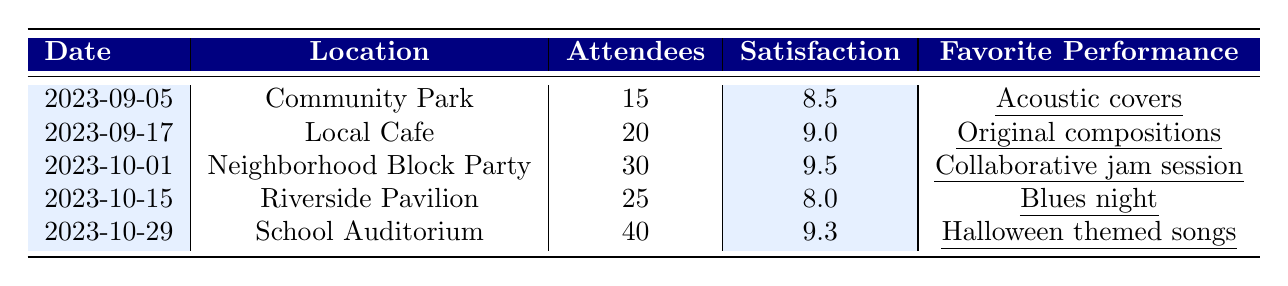What was the location for the music sharing session on September 17, 2023? The table lists the session date, location, attendees, satisfaction, and favorite performance for each session. For the date 2023-09-17, the location is Local Cafe.
Answer: Local Cafe How many attendees were present at the Neighborhood Block Party session? By referring to the row corresponding to the date 2023-10-01, we see that the number of attendees for the Neighborhood Block Party is 30.
Answer: 30 What was the satisfaction rating for the session held at Riverside Pavilion? The satisfaction rating for Riverside Pavilion corresponds to the date 2023-10-15 in the table, which shows a satisfaction rating of 8.0.
Answer: 8.0 Which performance received the highest satisfaction rating? We examine the satisfaction ratings in the table: 8.5, 9.0, 9.5, 8.0, and 9.3. The highest rating is 9.5, which corresponds to the Collaborative jam session on 2023-10-01.
Answer: Collaborative jam session How many attendees were at the sessions where the favorite performance was related to original music? The sessions with favorite performances of "Original compositions" (20 attendees) and "Collaborative jam session" (30 attendees) are the ones related to original music. Adding these gives 20 + 30 = 50 attendees.
Answer: 50 Was there a session where the satisfaction rating was below 8? By checking the satisfaction ratings, we find that the lowest rating is 8.0 (Riverside Pavilion, 2023-10-15). Therefore, there wasn't a session below that threshold.
Answer: No What is the average satisfaction rating across all the sessions? We sum the satisfaction ratings: 8.5 + 9.0 + 9.5 + 8.0 + 9.3 = 44.3. There are 5 sessions, so the average is 44.3 ÷ 5 = 8.86.
Answer: 8.86 How many sessions had more than 25 attendees? The sessions with more than 25 attendees are the Neighborhood Block Party (30), Riverside Pavilion (25), and School Auditorium (40). This totals to 3 sessions.
Answer: 3 What suggestions were given for the session on September 5, 2023? Looking at the feedback section for the session on 2023-09-05, the suggestion provided was "More outdoor sessions."
Answer: More outdoor sessions Which session had the highest number of attendees and what was the favorite performance? The session with the highest number of attendees is on 2023-10-29, with 40 attendees. The favorite performance for that session was "Halloween themed songs."
Answer: Halloween themed songs 